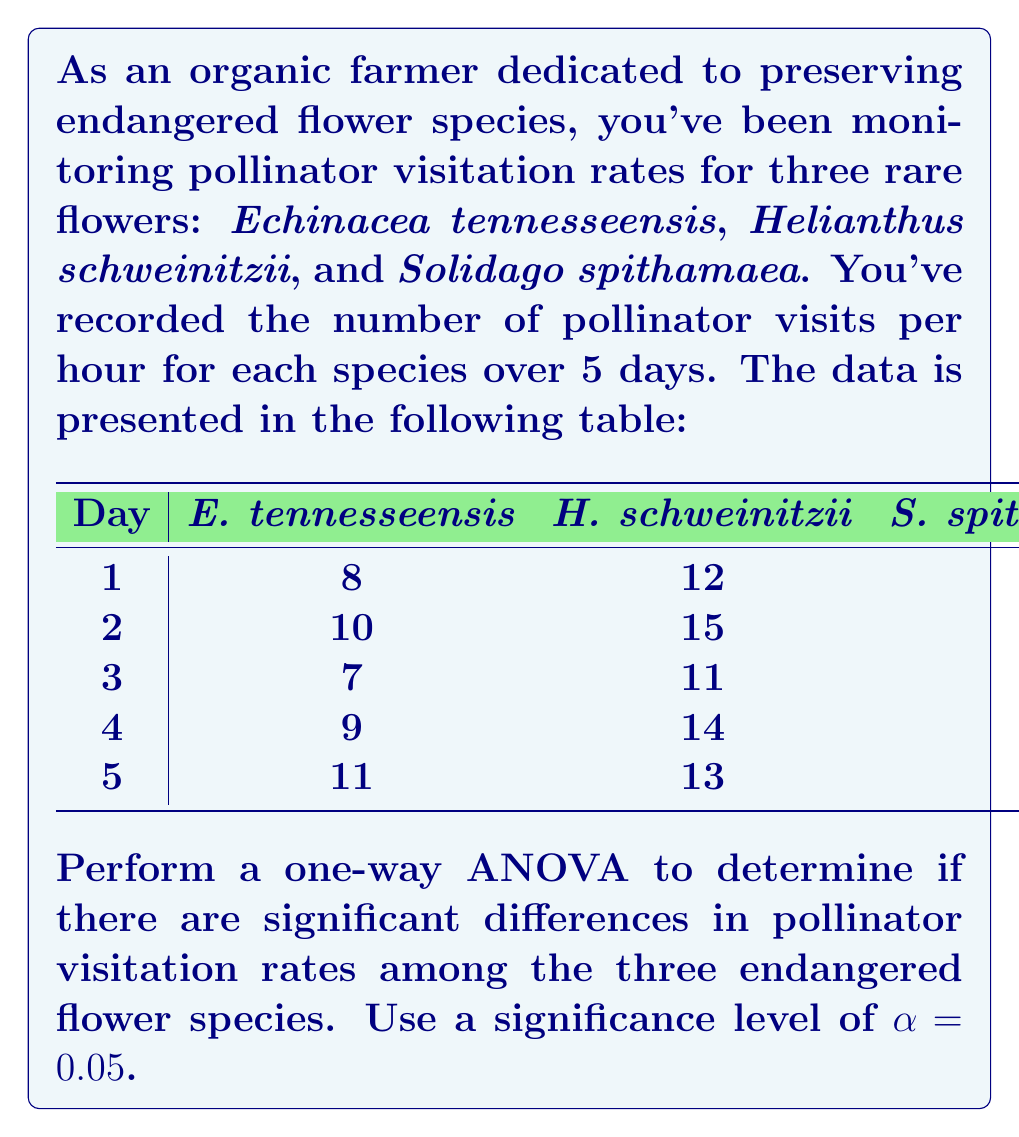Help me with this question. To perform a one-way ANOVA, we'll follow these steps:

1. Calculate the total sum of squares (SST)
2. Calculate the between-group sum of squares (SSB)
3. Calculate the within-group sum of squares (SSW)
4. Calculate degrees of freedom
5. Calculate mean squares
6. Calculate the F-statistic
7. Determine the critical F-value
8. Make a decision

Step 1: Calculate SST
First, we need to calculate the grand mean:
$\bar{X} = \frac{8+10+7+9+11+12+15+11+14+13+6+7+5+8+6}{15} = 9.467$

Now, we can calculate SST:
$$SST = \sum_{i=1}^{3}\sum_{j=1}^{5} (X_{ij} - \bar{X})^2 = 184.933$$

Step 2: Calculate SSB
Calculate the means for each group:
$\bar{X}_1 = 9$, $\bar{X}_2 = 13$, $\bar{X}_3 = 6.4$

$$SSB = 5[(9-9.467)^2 + (13-9.467)^2 + (6.4-9.467)^2] = 136.933$$

Step 3: Calculate SSW
$$SSW = SST - SSB = 184.933 - 136.933 = 48$$

Step 4: Degrees of freedom
$df_{between} = k - 1 = 3 - 1 = 2$
$df_{within} = N - k = 15 - 3 = 12$
$df_{total} = N - 1 = 15 - 1 = 14$

Step 5: Calculate mean squares
$MS_{between} = \frac{SSB}{df_{between}} = \frac{136.933}{2} = 68.467$
$MS_{within} = \frac{SSW}{df_{within}} = \frac{48}{12} = 4$

Step 6: Calculate F-statistic
$$F = \frac{MS_{between}}{MS_{within}} = \frac{68.467}{4} = 17.117$$

Step 7: Determine critical F-value
For $\alpha = 0.05$, $df_{between} = 2$, and $df_{within} = 12$, the critical F-value is approximately 3.89.

Step 8: Make a decision
Since the calculated F-statistic (17.117) is greater than the critical F-value (3.89), we reject the null hypothesis.
Answer: Reject null hypothesis; significant differences exist in pollinator visitation rates (F(2,12) = 17.117, p < 0.05). 